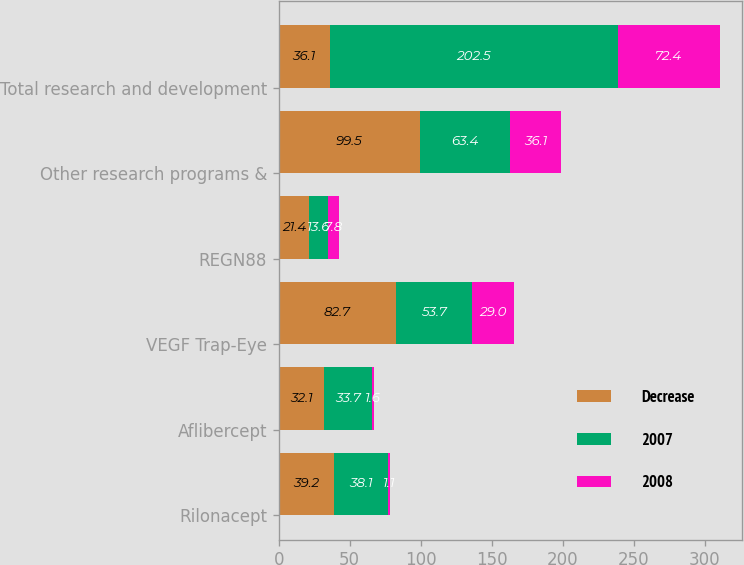Convert chart. <chart><loc_0><loc_0><loc_500><loc_500><stacked_bar_chart><ecel><fcel>Rilonacept<fcel>Aflibercept<fcel>VEGF Trap-Eye<fcel>REGN88<fcel>Other research programs &<fcel>Total research and development<nl><fcel>Decrease<fcel>39.2<fcel>32.1<fcel>82.7<fcel>21.4<fcel>99.5<fcel>36.1<nl><fcel>2007<fcel>38.1<fcel>33.7<fcel>53.7<fcel>13.6<fcel>63.4<fcel>202.5<nl><fcel>2008<fcel>1.1<fcel>1.6<fcel>29<fcel>7.8<fcel>36.1<fcel>72.4<nl></chart> 